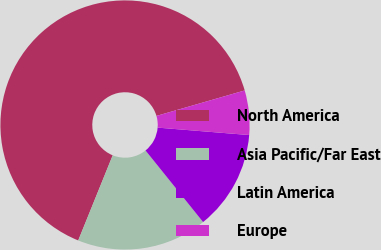Convert chart to OTSL. <chart><loc_0><loc_0><loc_500><loc_500><pie_chart><fcel>North America<fcel>Asia Pacific/Far East<fcel>Latin America<fcel>Europe<nl><fcel>64.41%<fcel>16.91%<fcel>12.93%<fcel>5.76%<nl></chart> 